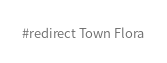<code> <loc_0><loc_0><loc_500><loc_500><_FORTRAN_>#redirect Town Flora
</code> 